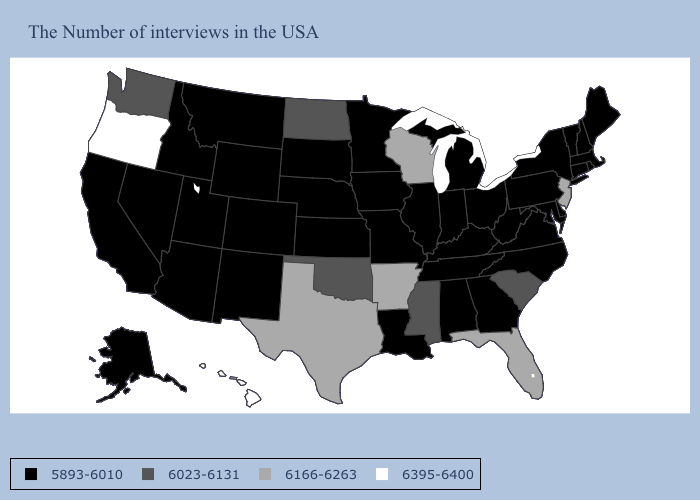Which states hav the highest value in the MidWest?
Be succinct. Wisconsin. Does New Hampshire have a lower value than Nevada?
Keep it brief. No. Which states have the highest value in the USA?
Concise answer only. Oregon, Hawaii. Name the states that have a value in the range 6395-6400?
Concise answer only. Oregon, Hawaii. How many symbols are there in the legend?
Answer briefly. 4. Which states hav the highest value in the South?
Write a very short answer. Florida, Arkansas, Texas. What is the value of West Virginia?
Be succinct. 5893-6010. Which states have the highest value in the USA?
Short answer required. Oregon, Hawaii. Name the states that have a value in the range 6023-6131?
Short answer required. South Carolina, Mississippi, Oklahoma, North Dakota, Washington. What is the value of West Virginia?
Short answer required. 5893-6010. How many symbols are there in the legend?
Answer briefly. 4. Name the states that have a value in the range 6166-6263?
Be succinct. New Jersey, Florida, Wisconsin, Arkansas, Texas. Among the states that border Mississippi , does Alabama have the lowest value?
Answer briefly. Yes. Name the states that have a value in the range 6023-6131?
Short answer required. South Carolina, Mississippi, Oklahoma, North Dakota, Washington. What is the highest value in the Northeast ?
Write a very short answer. 6166-6263. 